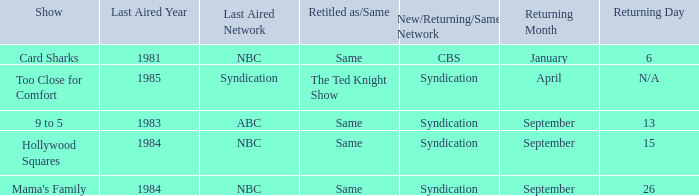What was the earliest aired show that's returning on September 13? 1983.0. 